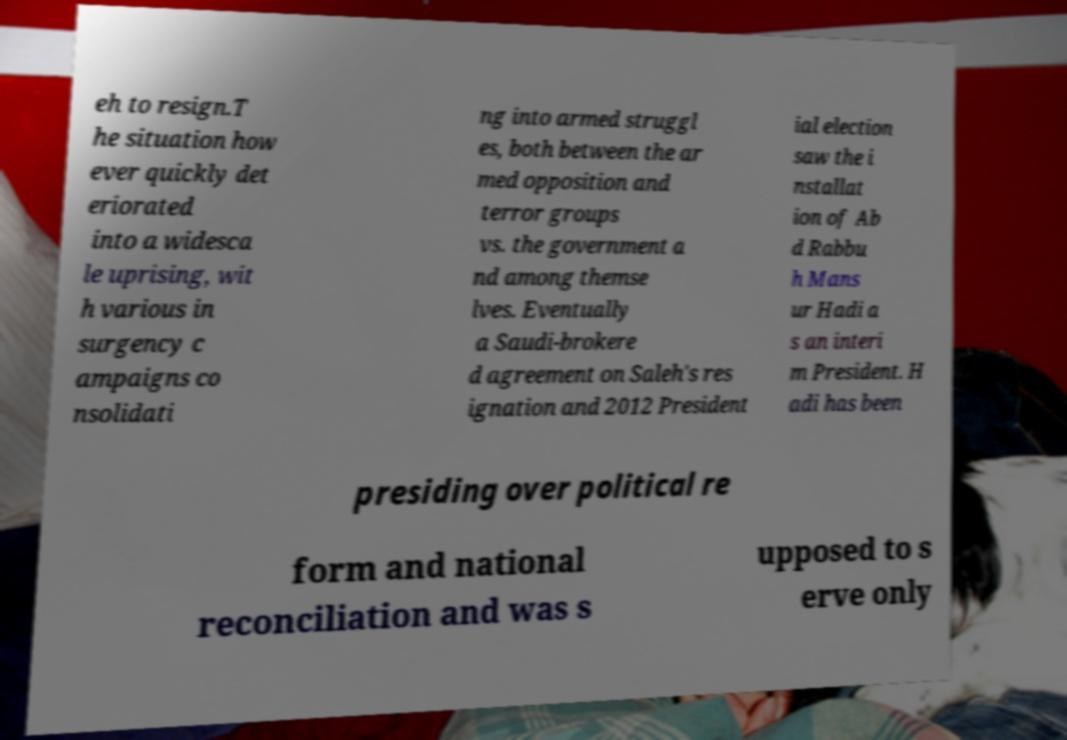Can you read and provide the text displayed in the image?This photo seems to have some interesting text. Can you extract and type it out for me? eh to resign.T he situation how ever quickly det eriorated into a widesca le uprising, wit h various in surgency c ampaigns co nsolidati ng into armed struggl es, both between the ar med opposition and terror groups vs. the government a nd among themse lves. Eventually a Saudi-brokere d agreement on Saleh's res ignation and 2012 President ial election saw the i nstallat ion of Ab d Rabbu h Mans ur Hadi a s an interi m President. H adi has been presiding over political re form and national reconciliation and was s upposed to s erve only 